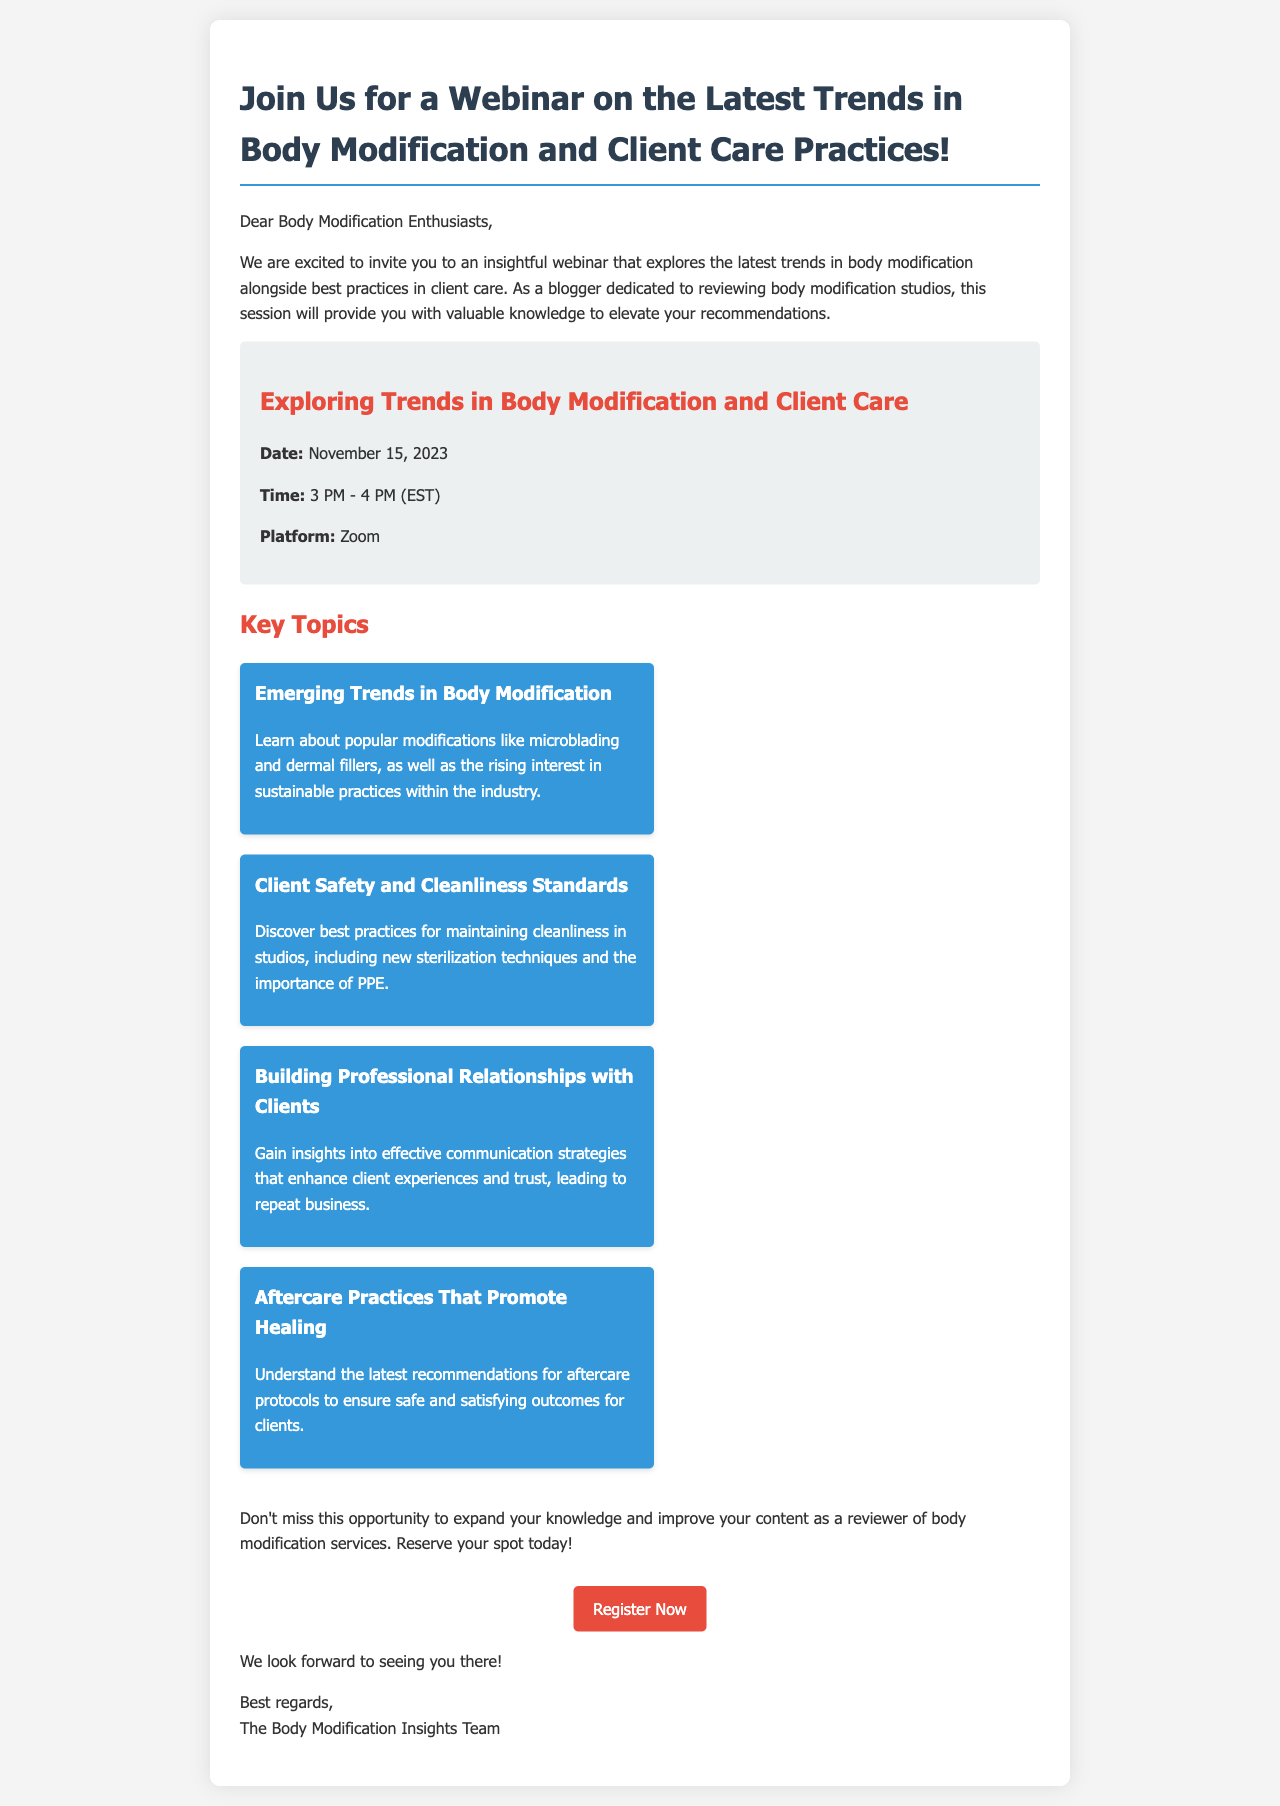What is the date of the webinar? The date of the webinar is mentioned in the document as November 15, 2023.
Answer: November 15, 2023 What time does the webinar start? The starting time of the webinar is given as 3 PM (EST).
Answer: 3 PM What platform will the webinar be held on? The document states that the webinar will be held on Zoom.
Answer: Zoom Name one key topic that will be discussed. The document lists several key topics, one of which is "Client Safety and Cleanliness Standards."
Answer: Client Safety and Cleanliness Standards What is one emerging trend mentioned in the webinar? The document mentions "microblading" as one of the popular modifications in emerging trends.
Answer: microblading How long is the webinar scheduled to last? The duration of the webinar is provided as 1 hour, from 3 PM to 4 PM.
Answer: 1 hour What type of communication strategies will be covered? The document discusses "effective communication strategies that enhance client experiences" as part of the webinar.
Answer: Effective communication strategies Who is the invitation from? The document states that the invitation is from "The Body Modification Insights Team."
Answer: The Body Modification Insights Team What do attendees need to do to participate in the webinar? Attendees are instructed to "Register Now" to reserve their spot for the webinar.
Answer: Register Now 